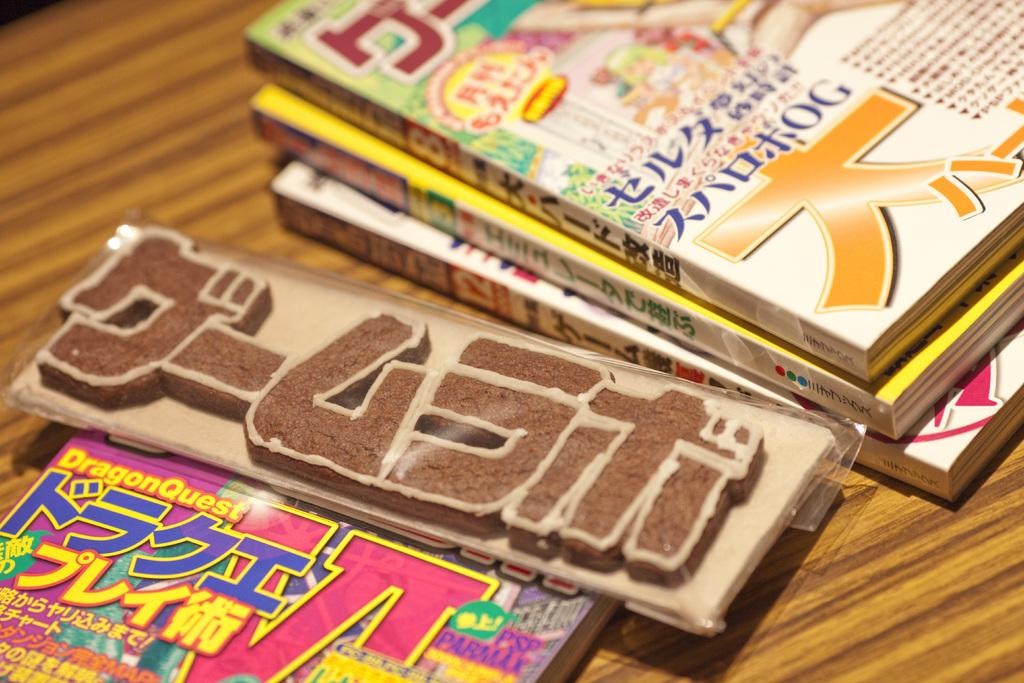<image>
Relay a brief, clear account of the picture shown. Three Japanese books sitting on top of each other on a table, and a small nameplate beside the books. 